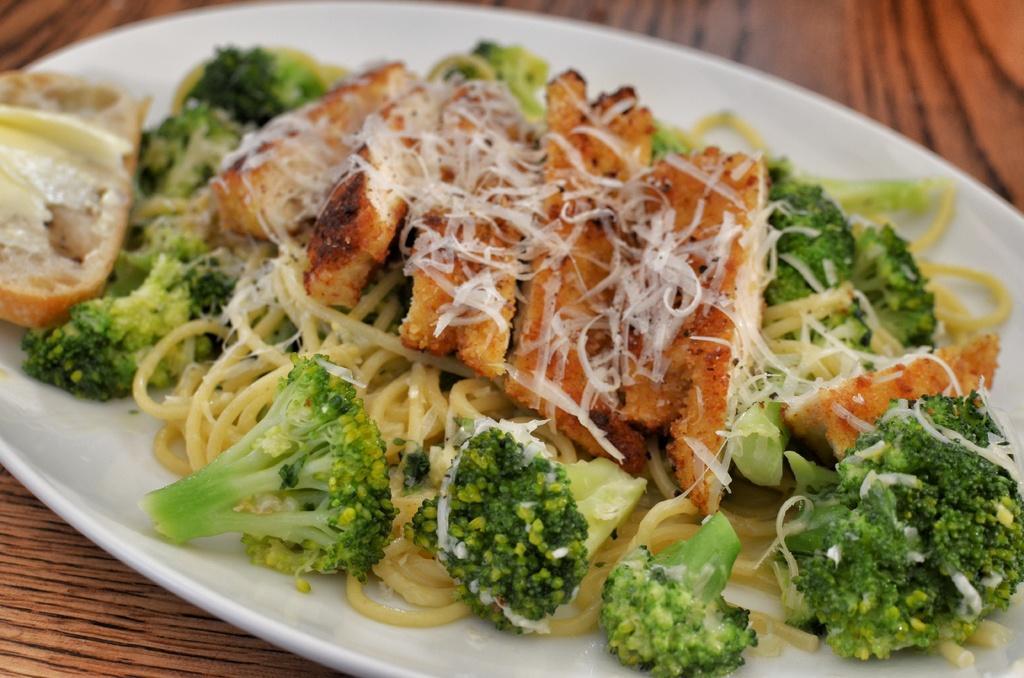Could you give a brief overview of what you see in this image? In this image we can see some food containing bread, broccoli, noodles and some cheese in a plate placed on the table. 